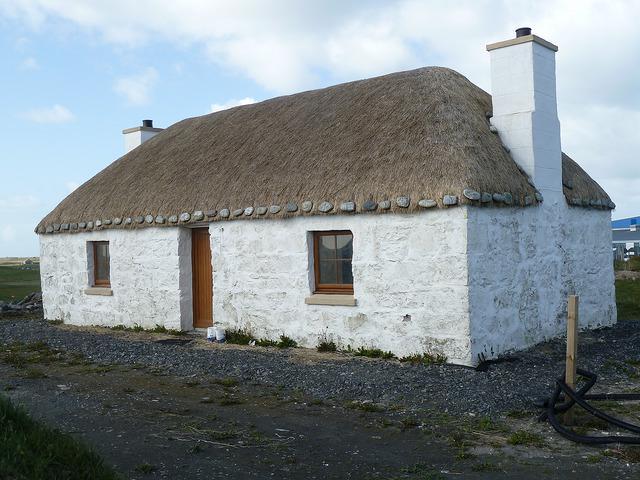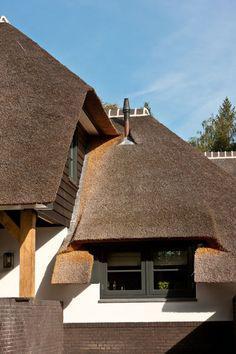The first image is the image on the left, the second image is the image on the right. For the images displayed, is the sentence "In at least one image there is a white house with two windows, a straw roof and two chimneys." factually correct? Answer yes or no. Yes. The first image is the image on the left, the second image is the image on the right. Evaluate the accuracy of this statement regarding the images: "One image shows a rectangular white building with a single window flanking each side of the door, a chimney on each end, and a roof with a straight bottom edge bordered with a dotted line of stones.". Is it true? Answer yes or no. Yes. 